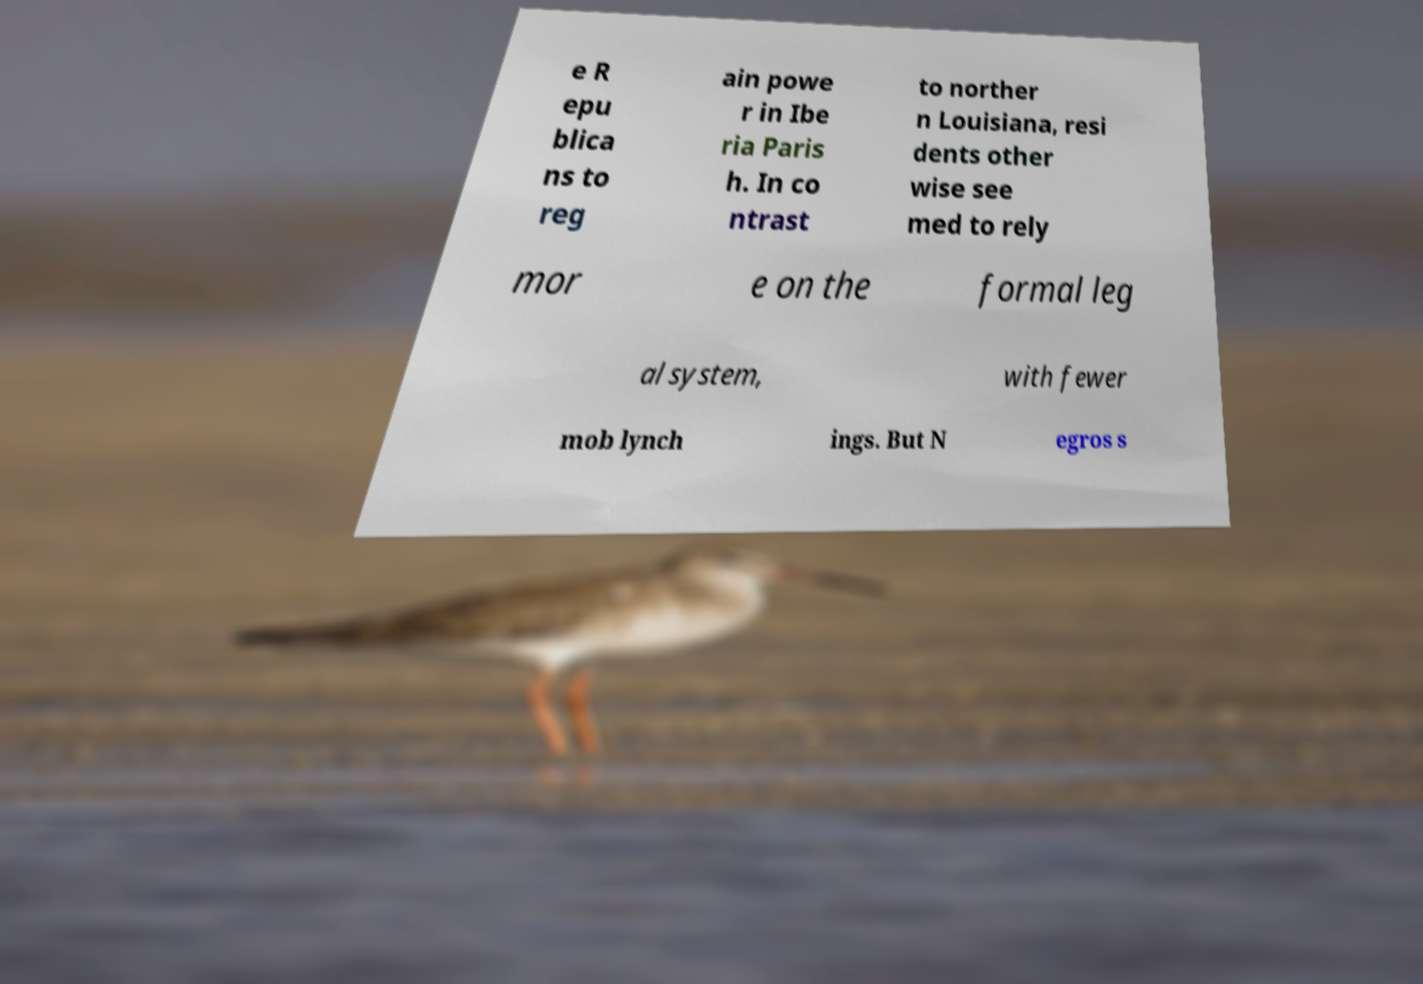Could you extract and type out the text from this image? e R epu blica ns to reg ain powe r in Ibe ria Paris h. In co ntrast to norther n Louisiana, resi dents other wise see med to rely mor e on the formal leg al system, with fewer mob lynch ings. But N egros s 